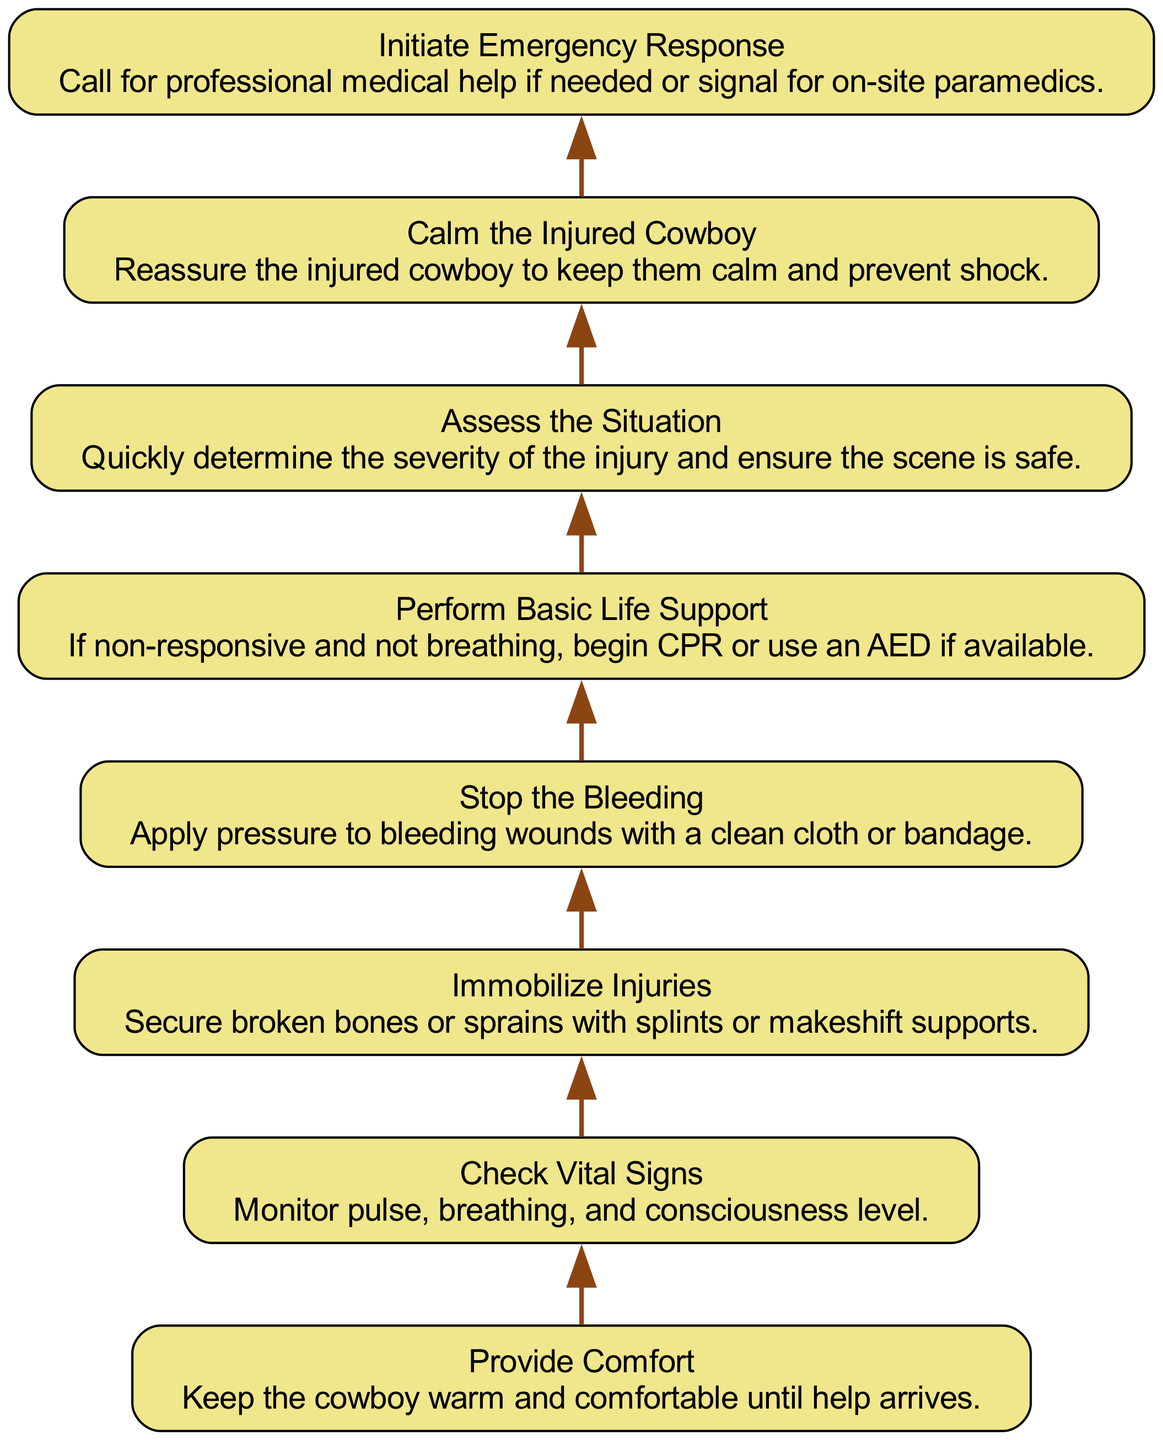What is the first step in the process? The first step, indicated as "Step1", is "Provide Comfort". This can be found at the bottom of the flowchart and emphasizes the initial action to keep the cowboy warm and comfortable.
Answer: Provide Comfort How many total steps are there in the flowchart? By reviewing the flowchart, we can count the steps listed from Step1 through Step8, giving us a total of eight steps in the process.
Answer: 8 What step comes after "Assess the Situation"? To determine which step follows "Assess the Situation", we trace the flow upward. "Assess the Situation" is Step6, and the next step is "Perform Basic Life Support," which is Step5.
Answer: Perform Basic Life Support What is the main action described in Step4? Step4 is titled "Stop the Bleeding," which describes the action of applying pressure to bleeding wounds using a clean cloth or bandage.
Answer: Stop the Bleeding What do you do if the cowboy is non-responsive? In the flowchart, the action specified for a non-responsive cowboy is to "Perform Basic Life Support," which includes beginning CPR or using an AED if available, as described in Step5.
Answer: Perform Basic Life Support Which step involves calming the injured cowboy? The flowchart indicates that calming the injured cowboy is explicitly described in Step7, titled "Calm the Injured Cowboy."
Answer: Calm the Injured Cowboy How does "Check Vital Signs" relate to "Immobilize Injuries"? In the flowchart, "Check Vital Signs" (Step2) comes before "Immobilize Injuries" (Step3) as part of the necessary assessments before stabilizing any injuries. This indicates that monitoring the injured cowboy's condition is a prerequisite to ensuring injured areas are securely supported.
Answer: Check Vital Signs What is the focus of Step8? Step8 is focused on "Initiate Emergency Response," which is about calling for professional medical help or signaling for on-site paramedics as needed.
Answer: Initiate Emergency Response 